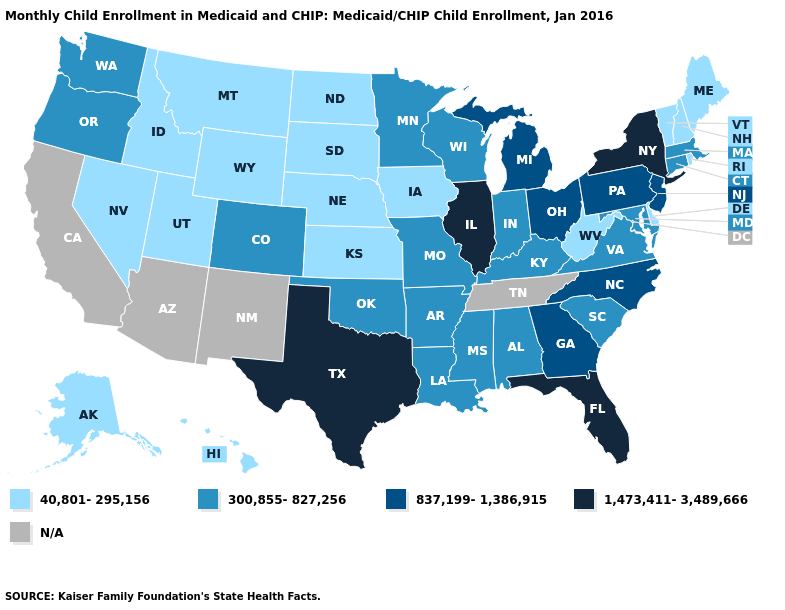What is the value of Iowa?
Give a very brief answer. 40,801-295,156. What is the highest value in the USA?
Keep it brief. 1,473,411-3,489,666. Name the states that have a value in the range 40,801-295,156?
Write a very short answer. Alaska, Delaware, Hawaii, Idaho, Iowa, Kansas, Maine, Montana, Nebraska, Nevada, New Hampshire, North Dakota, Rhode Island, South Dakota, Utah, Vermont, West Virginia, Wyoming. Among the states that border Ohio , which have the highest value?
Write a very short answer. Michigan, Pennsylvania. Does Florida have the highest value in the South?
Answer briefly. Yes. Name the states that have a value in the range N/A?
Be succinct. Arizona, California, New Mexico, Tennessee. Does Nevada have the lowest value in the West?
Give a very brief answer. Yes. What is the value of Rhode Island?
Short answer required. 40,801-295,156. Does New York have the highest value in the USA?
Short answer required. Yes. Does Minnesota have the highest value in the USA?
Concise answer only. No. What is the value of Colorado?
Keep it brief. 300,855-827,256. Does Hawaii have the highest value in the West?
Concise answer only. No. 